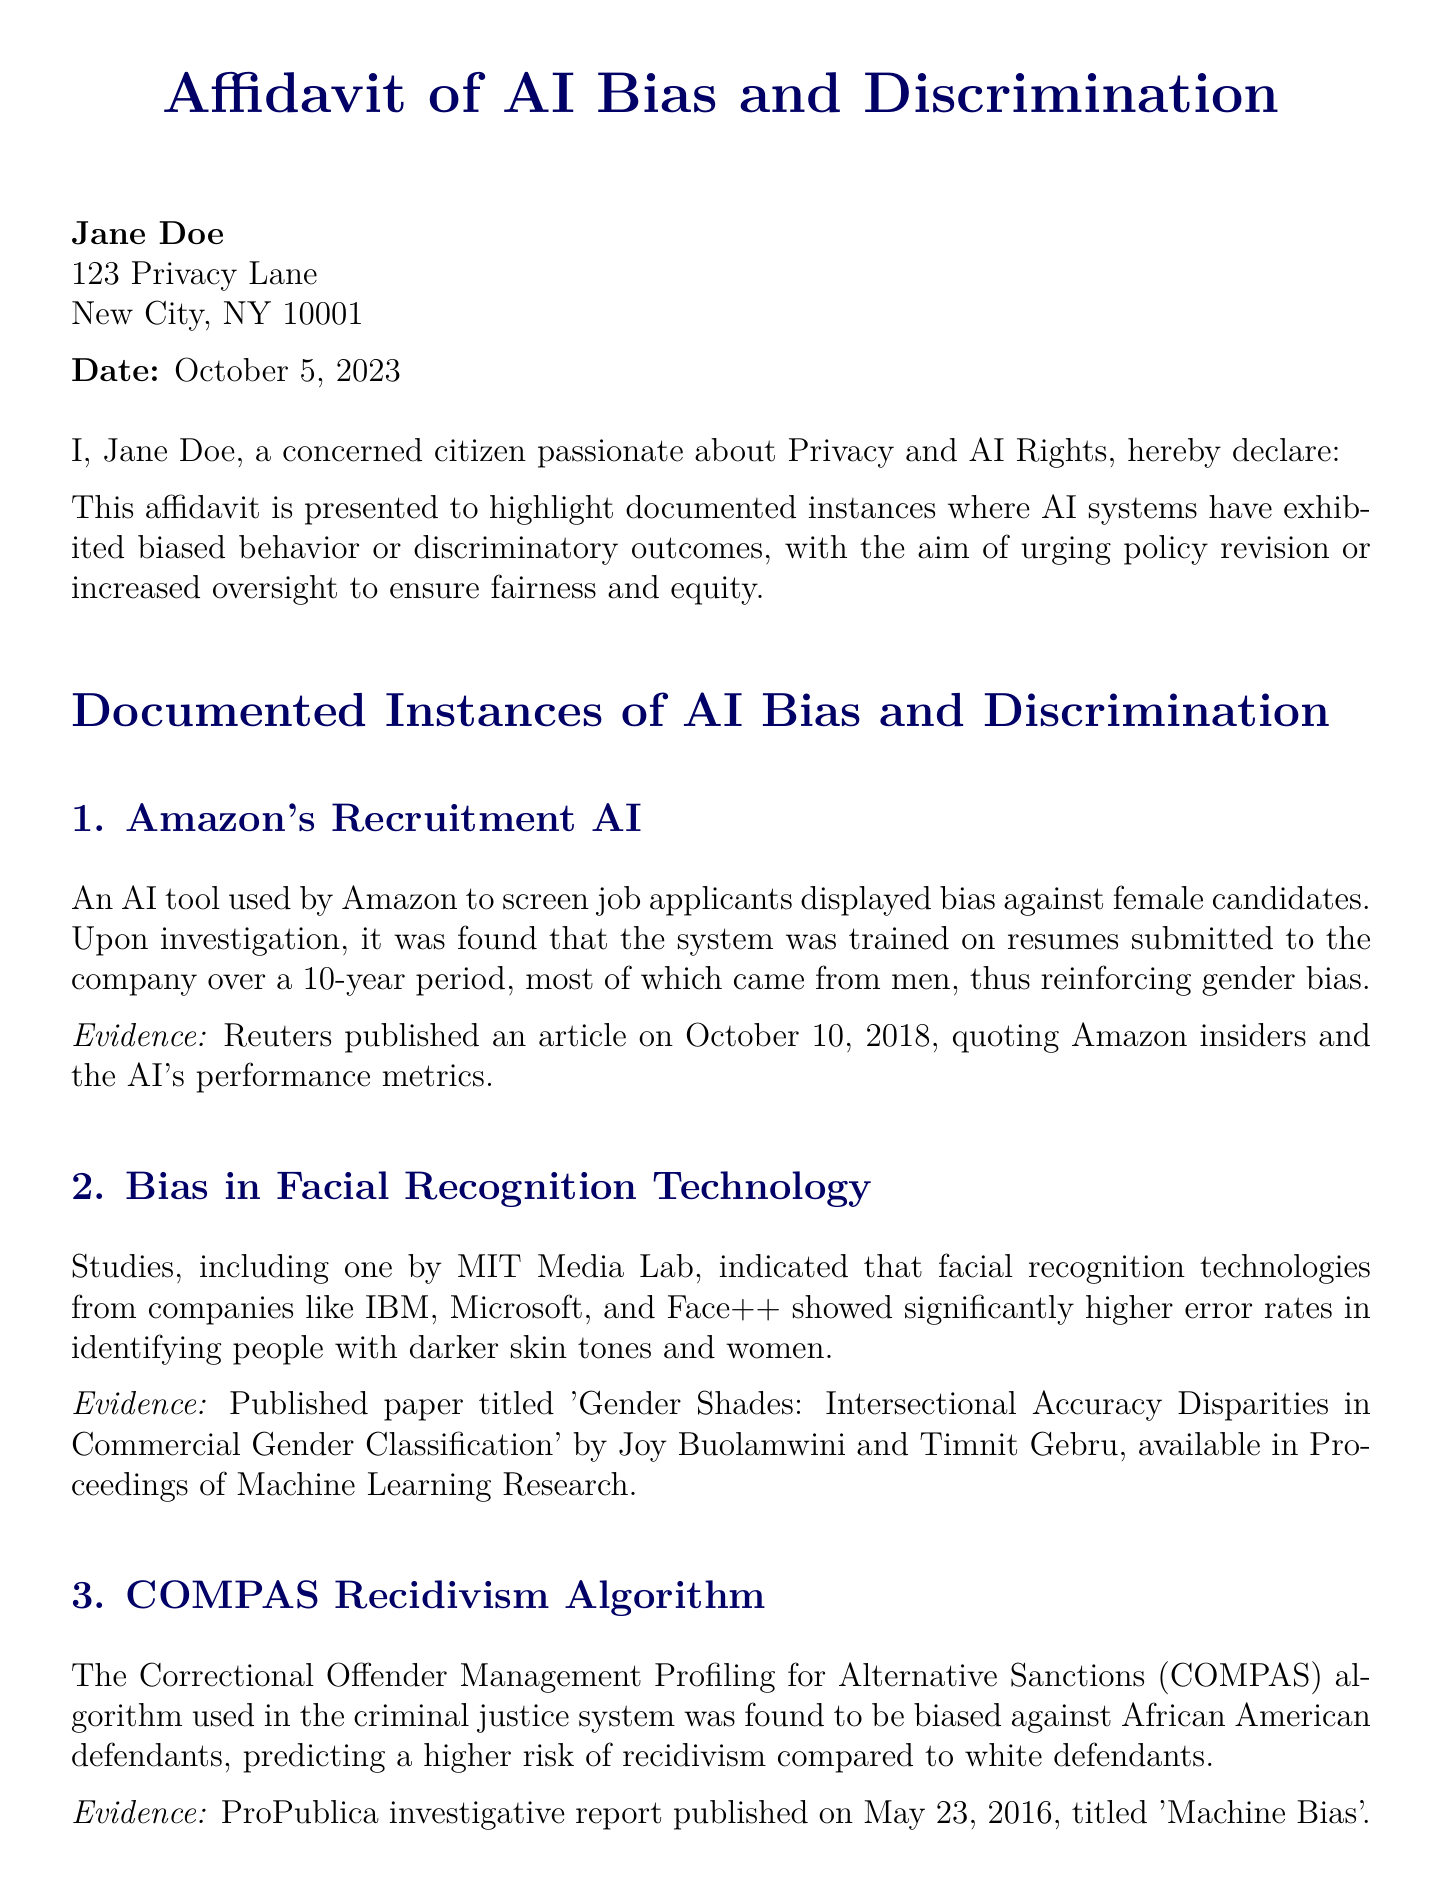What is the name of the affidavit? The name of the affidavit is presented in the title of the document.
Answer: Affidavit of AI Bias and Discrimination Who is the declarant of the affidavit? The declarant is introduced at the beginning of the document.
Answer: Jane Doe What date was the affidavit signed? The signing date is stated in the document.
Answer: October 5, 2023 What company’s recruitment AI is mentioned? The document references a specific company's AI system for context.
Answer: Amazon Which algorithm is cited as biased against African American defendants? The document specifies a title of an algorithm used in the criminal justice system.
Answer: COMPAS What is the main call to action in the affidavit? The last section of the document highlights the intended action.
Answer: Implement comprehensive policy revisions How many documented instances of AI bias are listed? The document enumerates specific cases of AI bias.
Answer: Four What publication reported on the Facial Recognition Technology study? The evidence section mentions the source of the study conducted by MIT Media Lab.
Answer: Proceedings of Machine Learning Research What was the study's title that discussed racial bias in healthcare algorithms? The document provides a title for the study addressing healthcare discrimination.
Answer: Dissecting racial bias in an algorithm used to manage the health of populations 